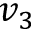<formula> <loc_0><loc_0><loc_500><loc_500>v _ { 3 }</formula> 